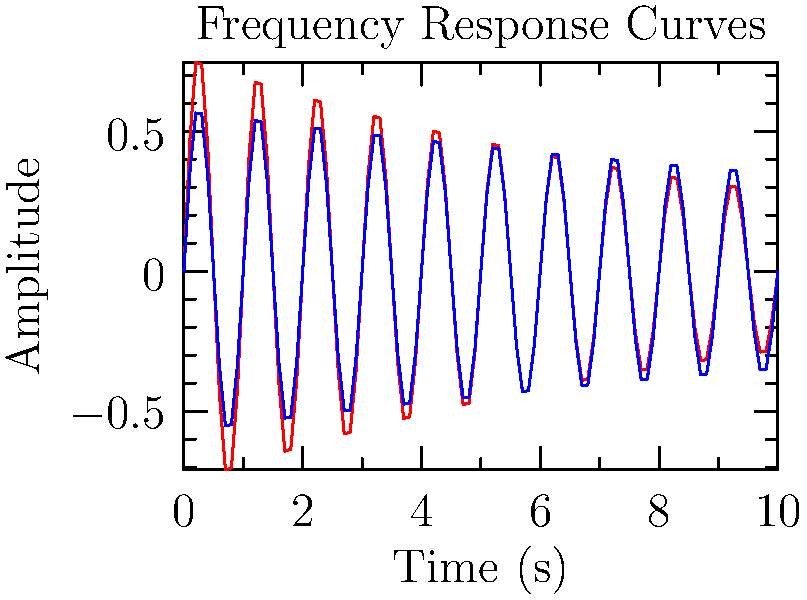Analyze the frequency response curves shown in the graph for two different supplements (A and B) and their effects on muscle contractions. Which supplement appears to have a longer-lasting effect on muscle contractions, and what electrical engineering concept does this relate to? To analyze the frequency response curves and determine which supplement has a longer-lasting effect, we need to consider the following steps:

1. Observe the decay rates: Both curves show a decaying sinusoidal pattern, typical of damped oscillations.

2. Compare the envelopes: The envelope of each curve represents the overall decay of the signal amplitude over time.
   - Supplement A (red curve): Decays more rapidly
   - Supplement B (blue curve): Decays more slowly

3. Relate to time constants: In electrical engineering, the time constant $\tau$ is related to the decay rate of an exponential function $e^{-t/\tau}$.
   - A larger time constant results in a slower decay.
   - Supplement B has a larger time constant, evident from its slower decay.

4. Consider the quality factor (Q): In frequency response analysis, the Q factor is related to how quickly oscillations decay.
   - Higher Q factor = slower decay = longer-lasting effect
   - Supplement B exhibits a higher Q factor

5. Relate to electrical engineering concepts: This behavior is analogous to the frequency response of RLC circuits or filters, where:
   - The decay rate is related to the damping factor
   - The oscillation frequency is related to the natural frequency
   - The Q factor determines the sharpness of the resonance peak

Therefore, Supplement B appears to have a longer-lasting effect on muscle contractions. This relates to the concept of time constants and quality factors in electrical engineering frequency response analysis.
Answer: Supplement B; time constant and quality factor 